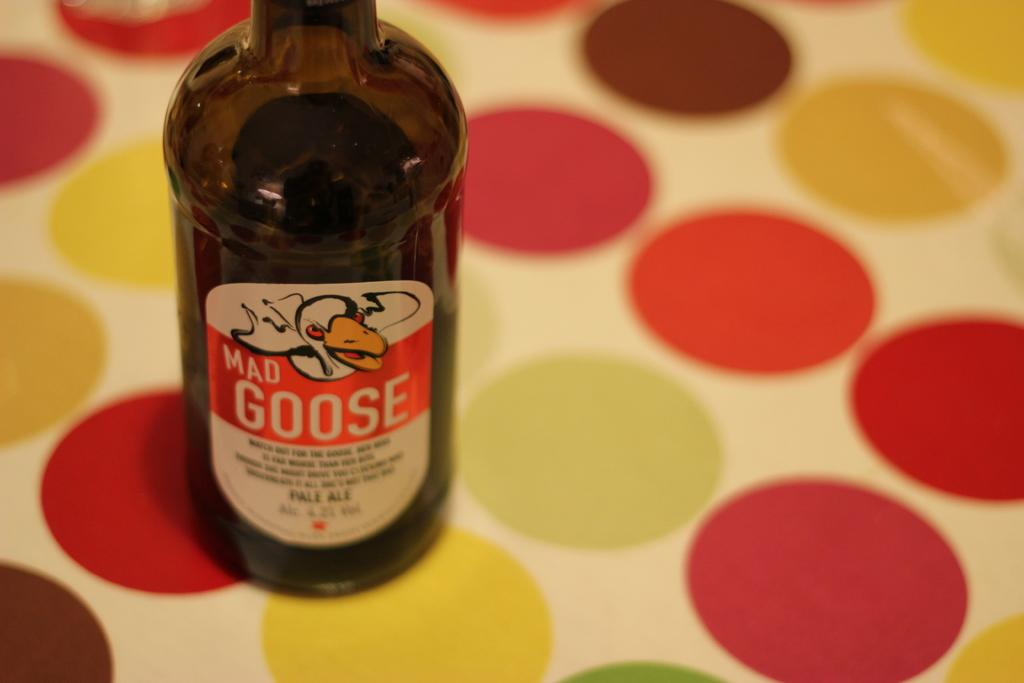<image>
Relay a brief, clear account of the picture shown. Mad Goose beer bottle on top of a red and yellow polka dotted table. 